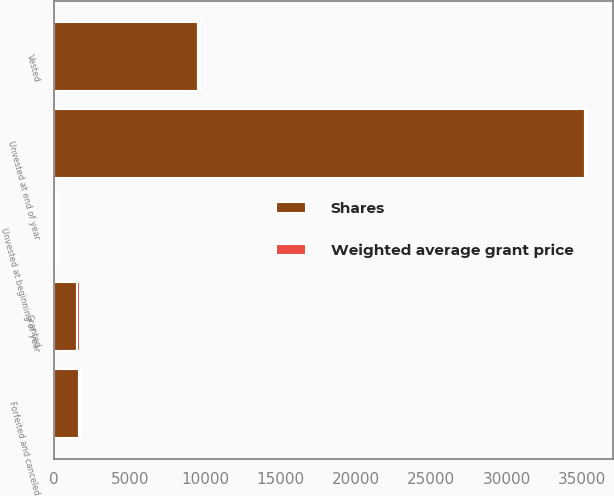<chart> <loc_0><loc_0><loc_500><loc_500><stacked_bar_chart><ecel><fcel>Unvested at beginning of year<fcel>Granted<fcel>Vested<fcel>Forfeited and canceled<fcel>Unvested at end of year<nl><fcel>Shares<fcel>134.44<fcel>1540<fcel>9532<fcel>1666<fcel>35219<nl><fcel>Weighted average grant price<fcel>102.46<fcel>134.44<fcel>104.91<fcel>94.35<fcel>98.57<nl></chart> 